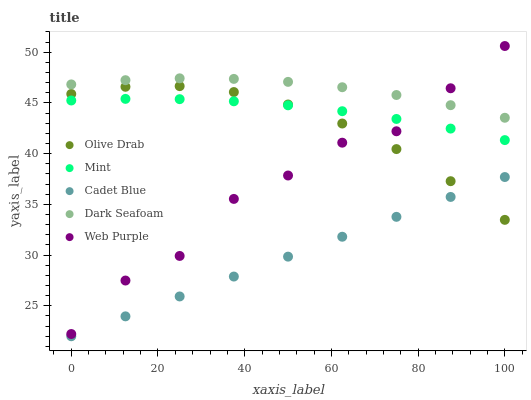Does Cadet Blue have the minimum area under the curve?
Answer yes or no. Yes. Does Dark Seafoam have the maximum area under the curve?
Answer yes or no. Yes. Does Mint have the minimum area under the curve?
Answer yes or no. No. Does Mint have the maximum area under the curve?
Answer yes or no. No. Is Cadet Blue the smoothest?
Answer yes or no. Yes. Is Web Purple the roughest?
Answer yes or no. Yes. Is Mint the smoothest?
Answer yes or no. No. Is Mint the roughest?
Answer yes or no. No. Does Cadet Blue have the lowest value?
Answer yes or no. Yes. Does Mint have the lowest value?
Answer yes or no. No. Does Web Purple have the highest value?
Answer yes or no. Yes. Does Mint have the highest value?
Answer yes or no. No. Is Cadet Blue less than Web Purple?
Answer yes or no. Yes. Is Dark Seafoam greater than Mint?
Answer yes or no. Yes. Does Web Purple intersect Dark Seafoam?
Answer yes or no. Yes. Is Web Purple less than Dark Seafoam?
Answer yes or no. No. Is Web Purple greater than Dark Seafoam?
Answer yes or no. No. Does Cadet Blue intersect Web Purple?
Answer yes or no. No. 